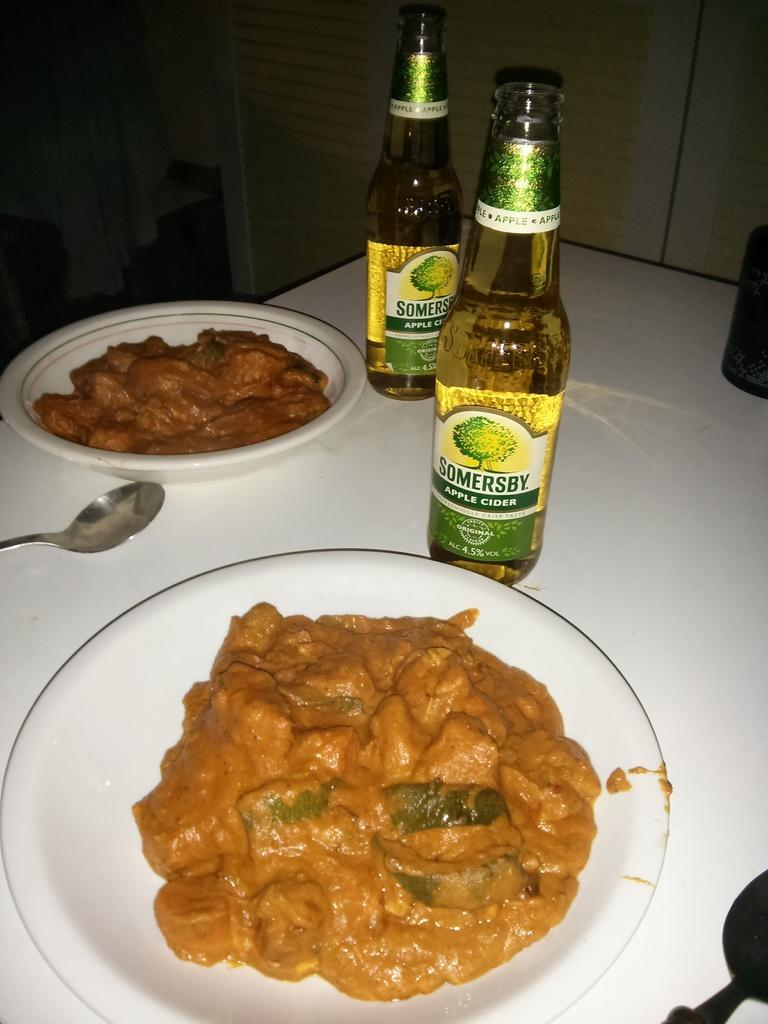<image>
Present a compact description of the photo's key features. Two bottles of Somersby Apple cider next to a plate of food. 